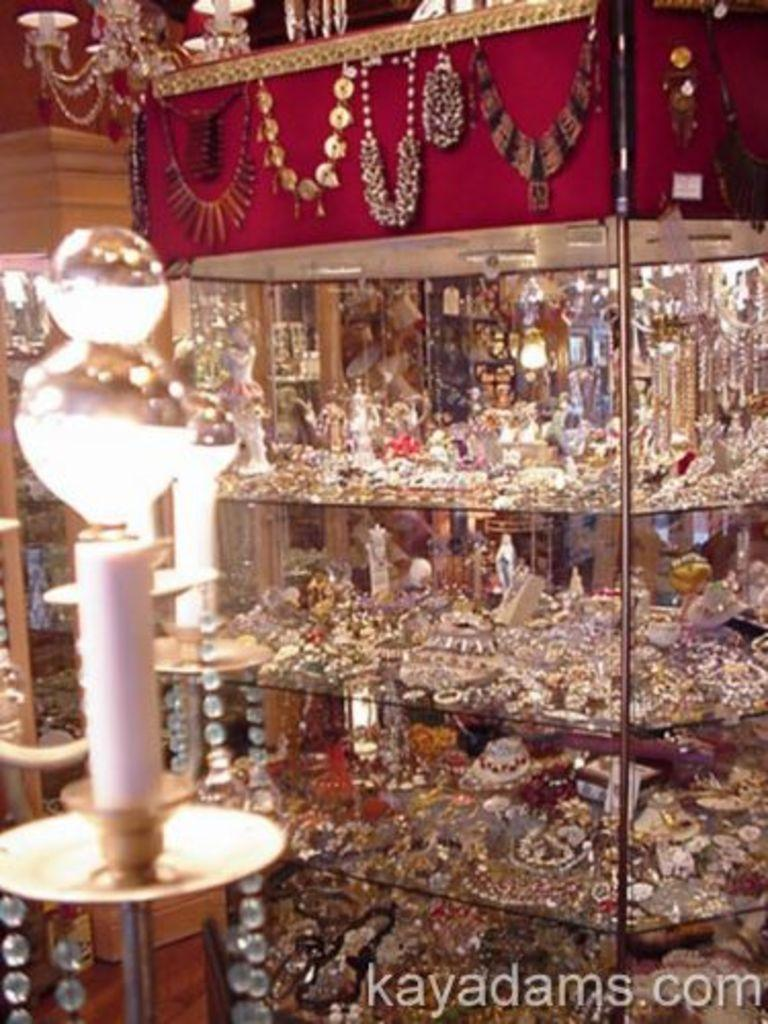What type of items are displayed on the shelves in the image? There are jewelries on shelves in the image. Can you describe any other jewelries visible in the image? Yes, there are additional jewelries visible in the image. Is there any other notable feature in the image? Yes, there is a watermark in the image. How many feet are visible in the image? There are no feet visible in the image; it primarily features jewelries on shelves and additional jewelries. 